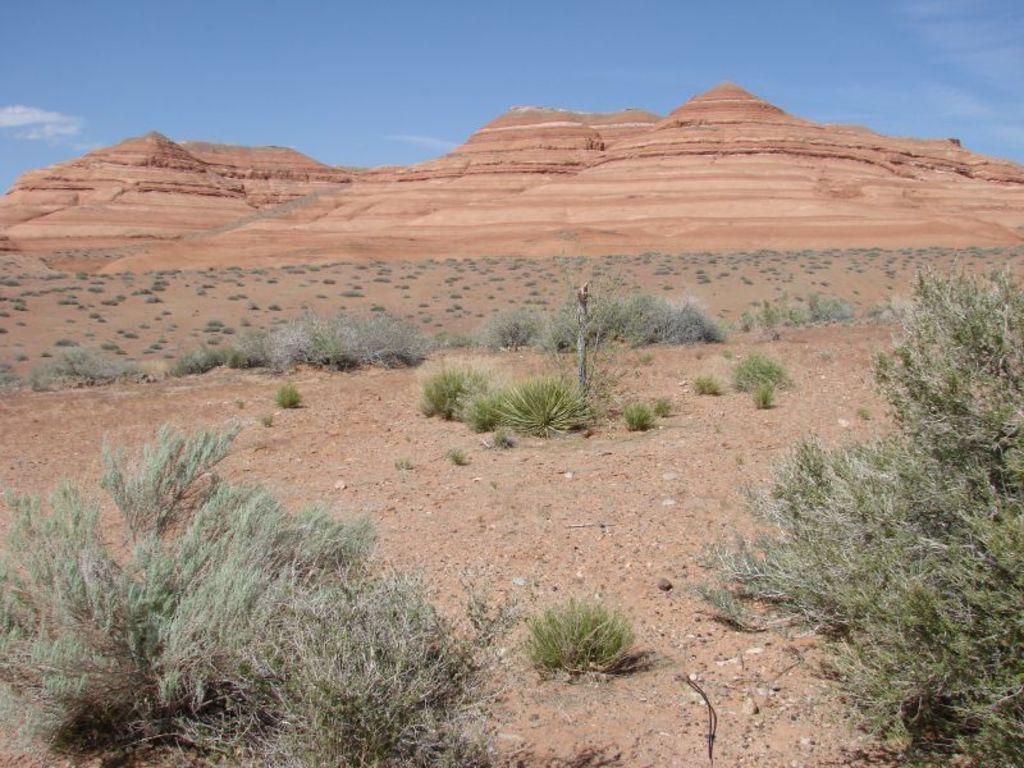In one or two sentences, can you explain what this image depicts? In this image there are rock formation cliffs, grass, few plants, sand and some clouds in the sky. 